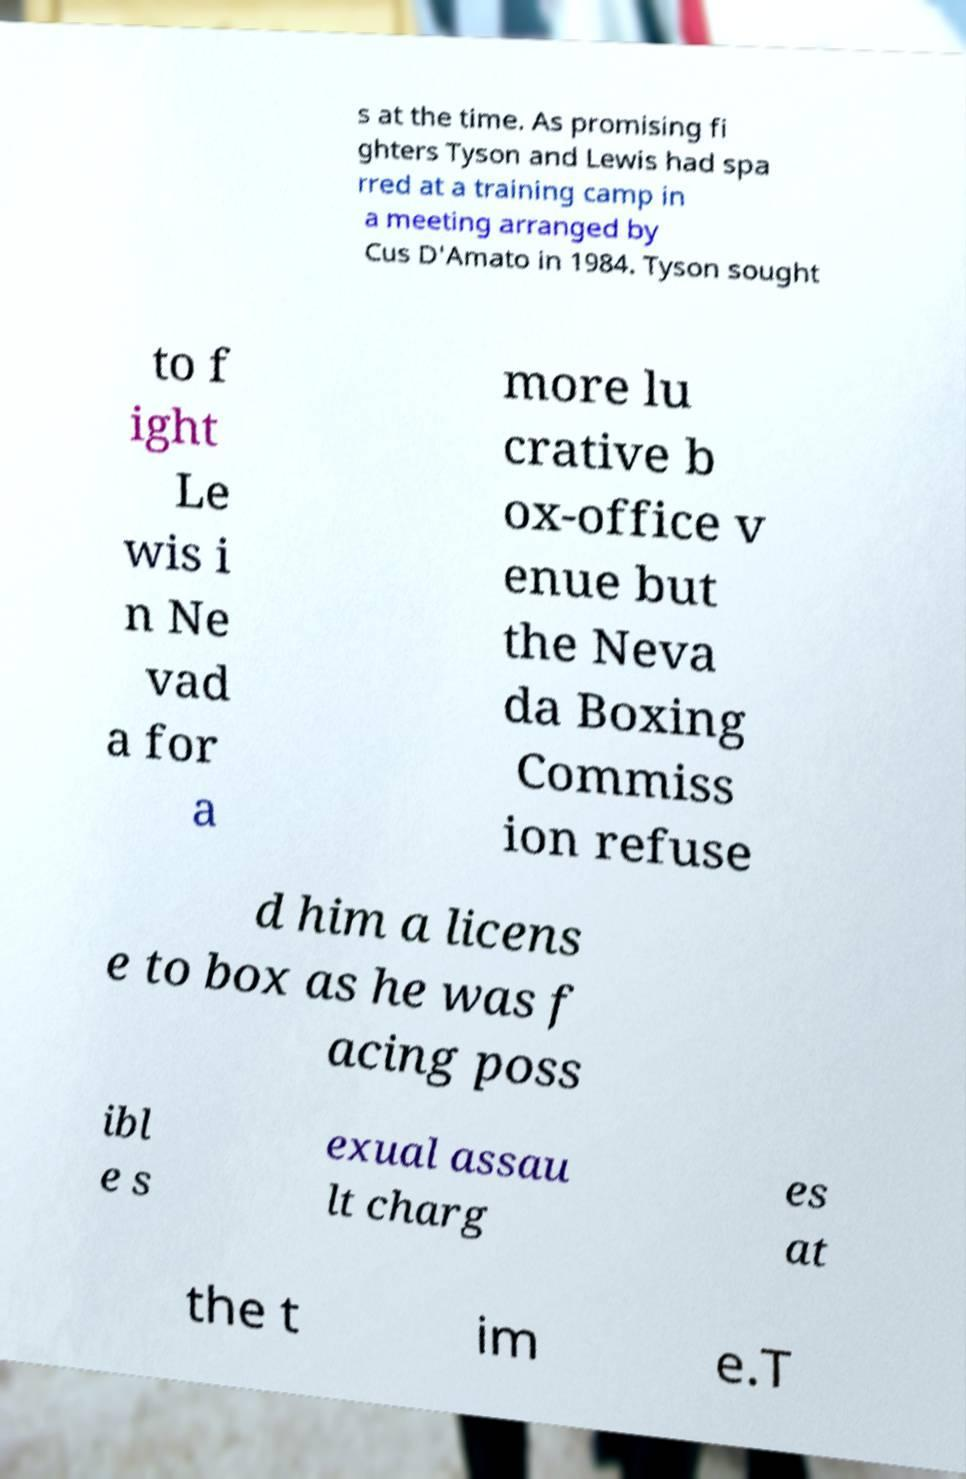What messages or text are displayed in this image? I need them in a readable, typed format. s at the time. As promising fi ghters Tyson and Lewis had spa rred at a training camp in a meeting arranged by Cus D'Amato in 1984. Tyson sought to f ight Le wis i n Ne vad a for a more lu crative b ox-office v enue but the Neva da Boxing Commiss ion refuse d him a licens e to box as he was f acing poss ibl e s exual assau lt charg es at the t im e.T 